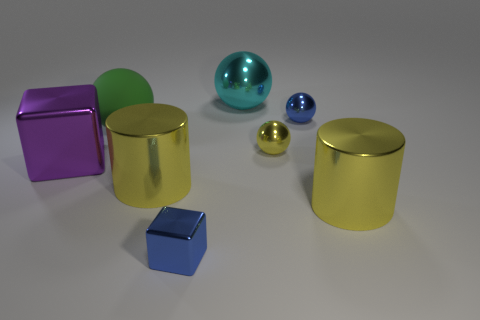Is the number of green objects behind the big matte object greater than the number of blocks?
Provide a short and direct response. No. There is a yellow thing in front of the big yellow thing that is on the left side of the large metal thing that is behind the big green matte object; what shape is it?
Provide a succinct answer. Cylinder. Do the tiny blue thing in front of the large block and the small blue object that is on the right side of the blue shiny cube have the same shape?
Offer a terse response. No. Is there anything else that has the same size as the matte thing?
Your response must be concise. Yes. What number of cubes are brown matte objects or big purple objects?
Make the answer very short. 1. Is the material of the small blue sphere the same as the purple thing?
Provide a short and direct response. Yes. What number of other things are there of the same color as the big rubber sphere?
Make the answer very short. 0. There is a small blue object that is in front of the large metal cube; what is its shape?
Ensure brevity in your answer.  Cube. How many things are small yellow shiny things or green rubber objects?
Provide a short and direct response. 2. Is the size of the yellow metal ball the same as the blue thing that is behind the tiny blue shiny block?
Make the answer very short. Yes. 